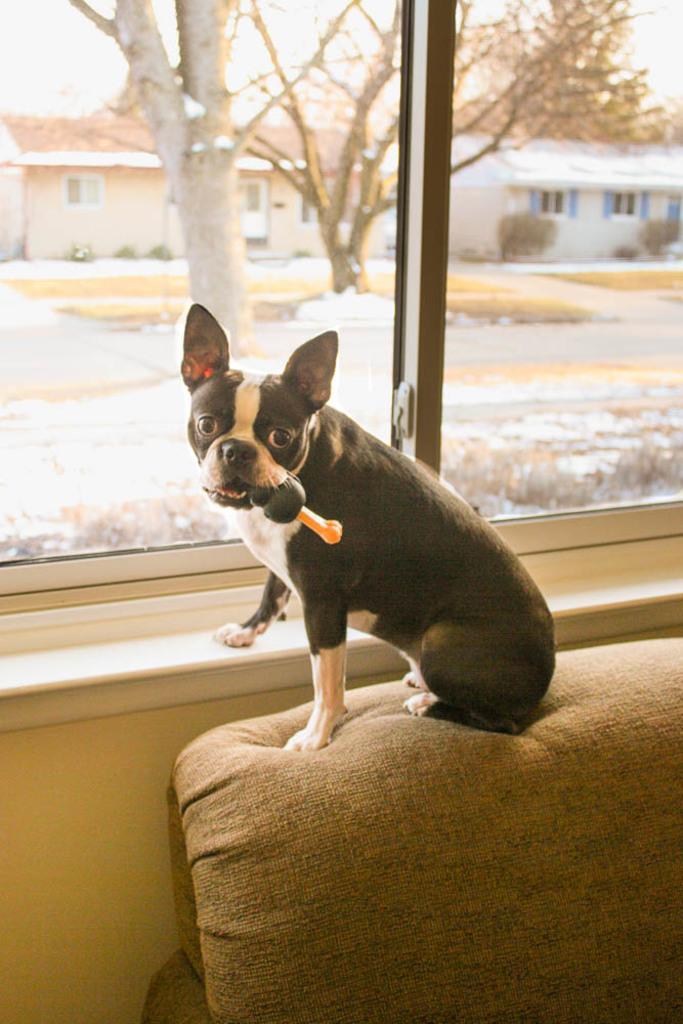Could you give a brief overview of what you see in this image? This is an inside view. Here I can see a dog sitting on a couch and looking at the picture. It is holding an object in the mouth. Behind there is a window glass through which we can see the outside view. In outside I can see a road, trees and a building. 